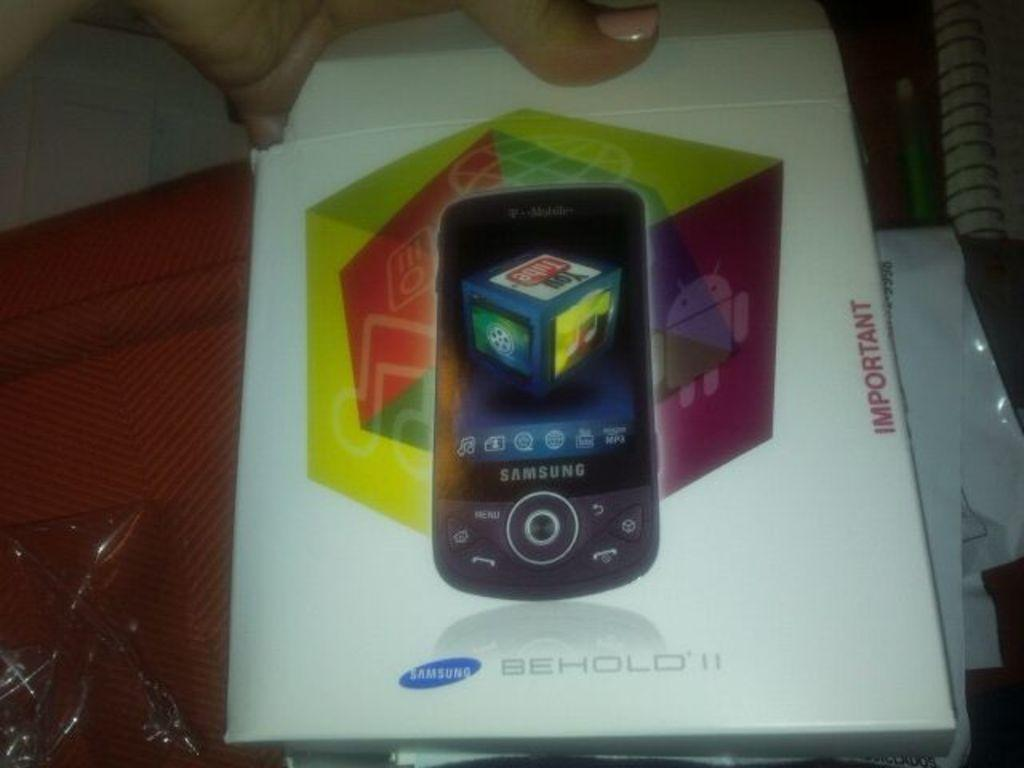<image>
Provide a brief description of the given image. An envelope for a Samsung phone is marked as important. 